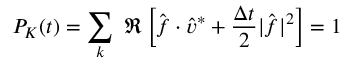<formula> <loc_0><loc_0><loc_500><loc_500>P _ { K } ( t ) = \sum _ { k } \Re \left [ \hat { f } \cdot \hat { v } ^ { * } + \frac { \Delta t } { 2 } | \hat { f } | ^ { 2 } \right ] = 1</formula> 